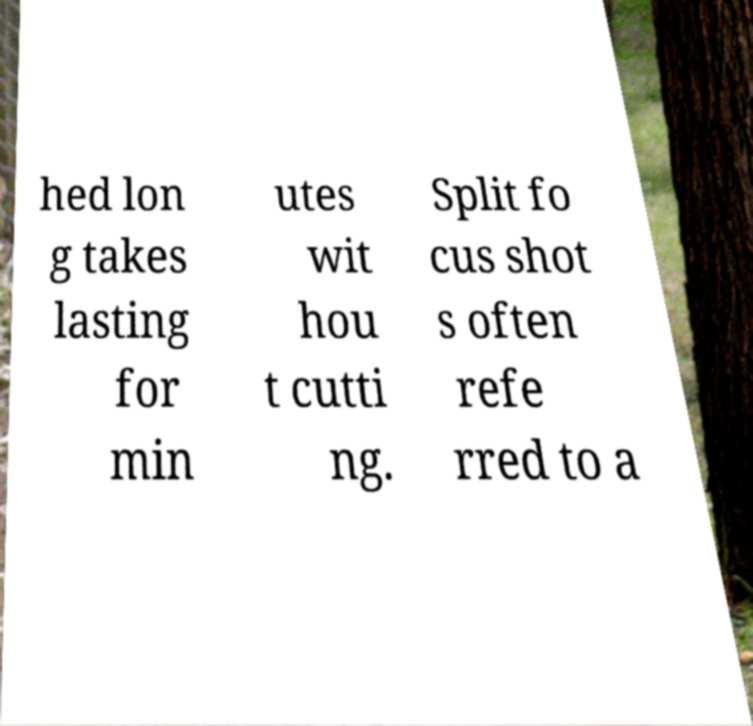Could you extract and type out the text from this image? hed lon g takes lasting for min utes wit hou t cutti ng. Split fo cus shot s often refe rred to a 